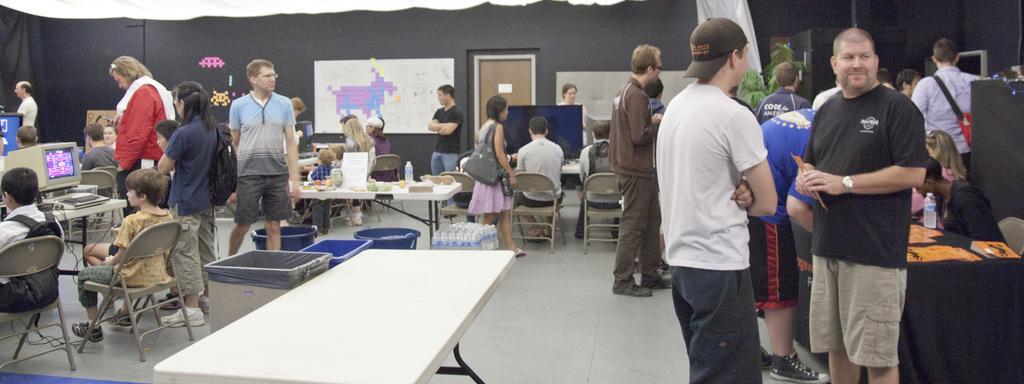How would you summarize this image in a sentence or two? In this picture there are many kids sitting on the chairs and operating the monitors. There are few people standing and guiding them. In the center of the image we observe white table and few trash cans between them. There are also few bunch of water bottles kept on the floor. In the right side of the image there is a black table on top of which registrations are being processed. 